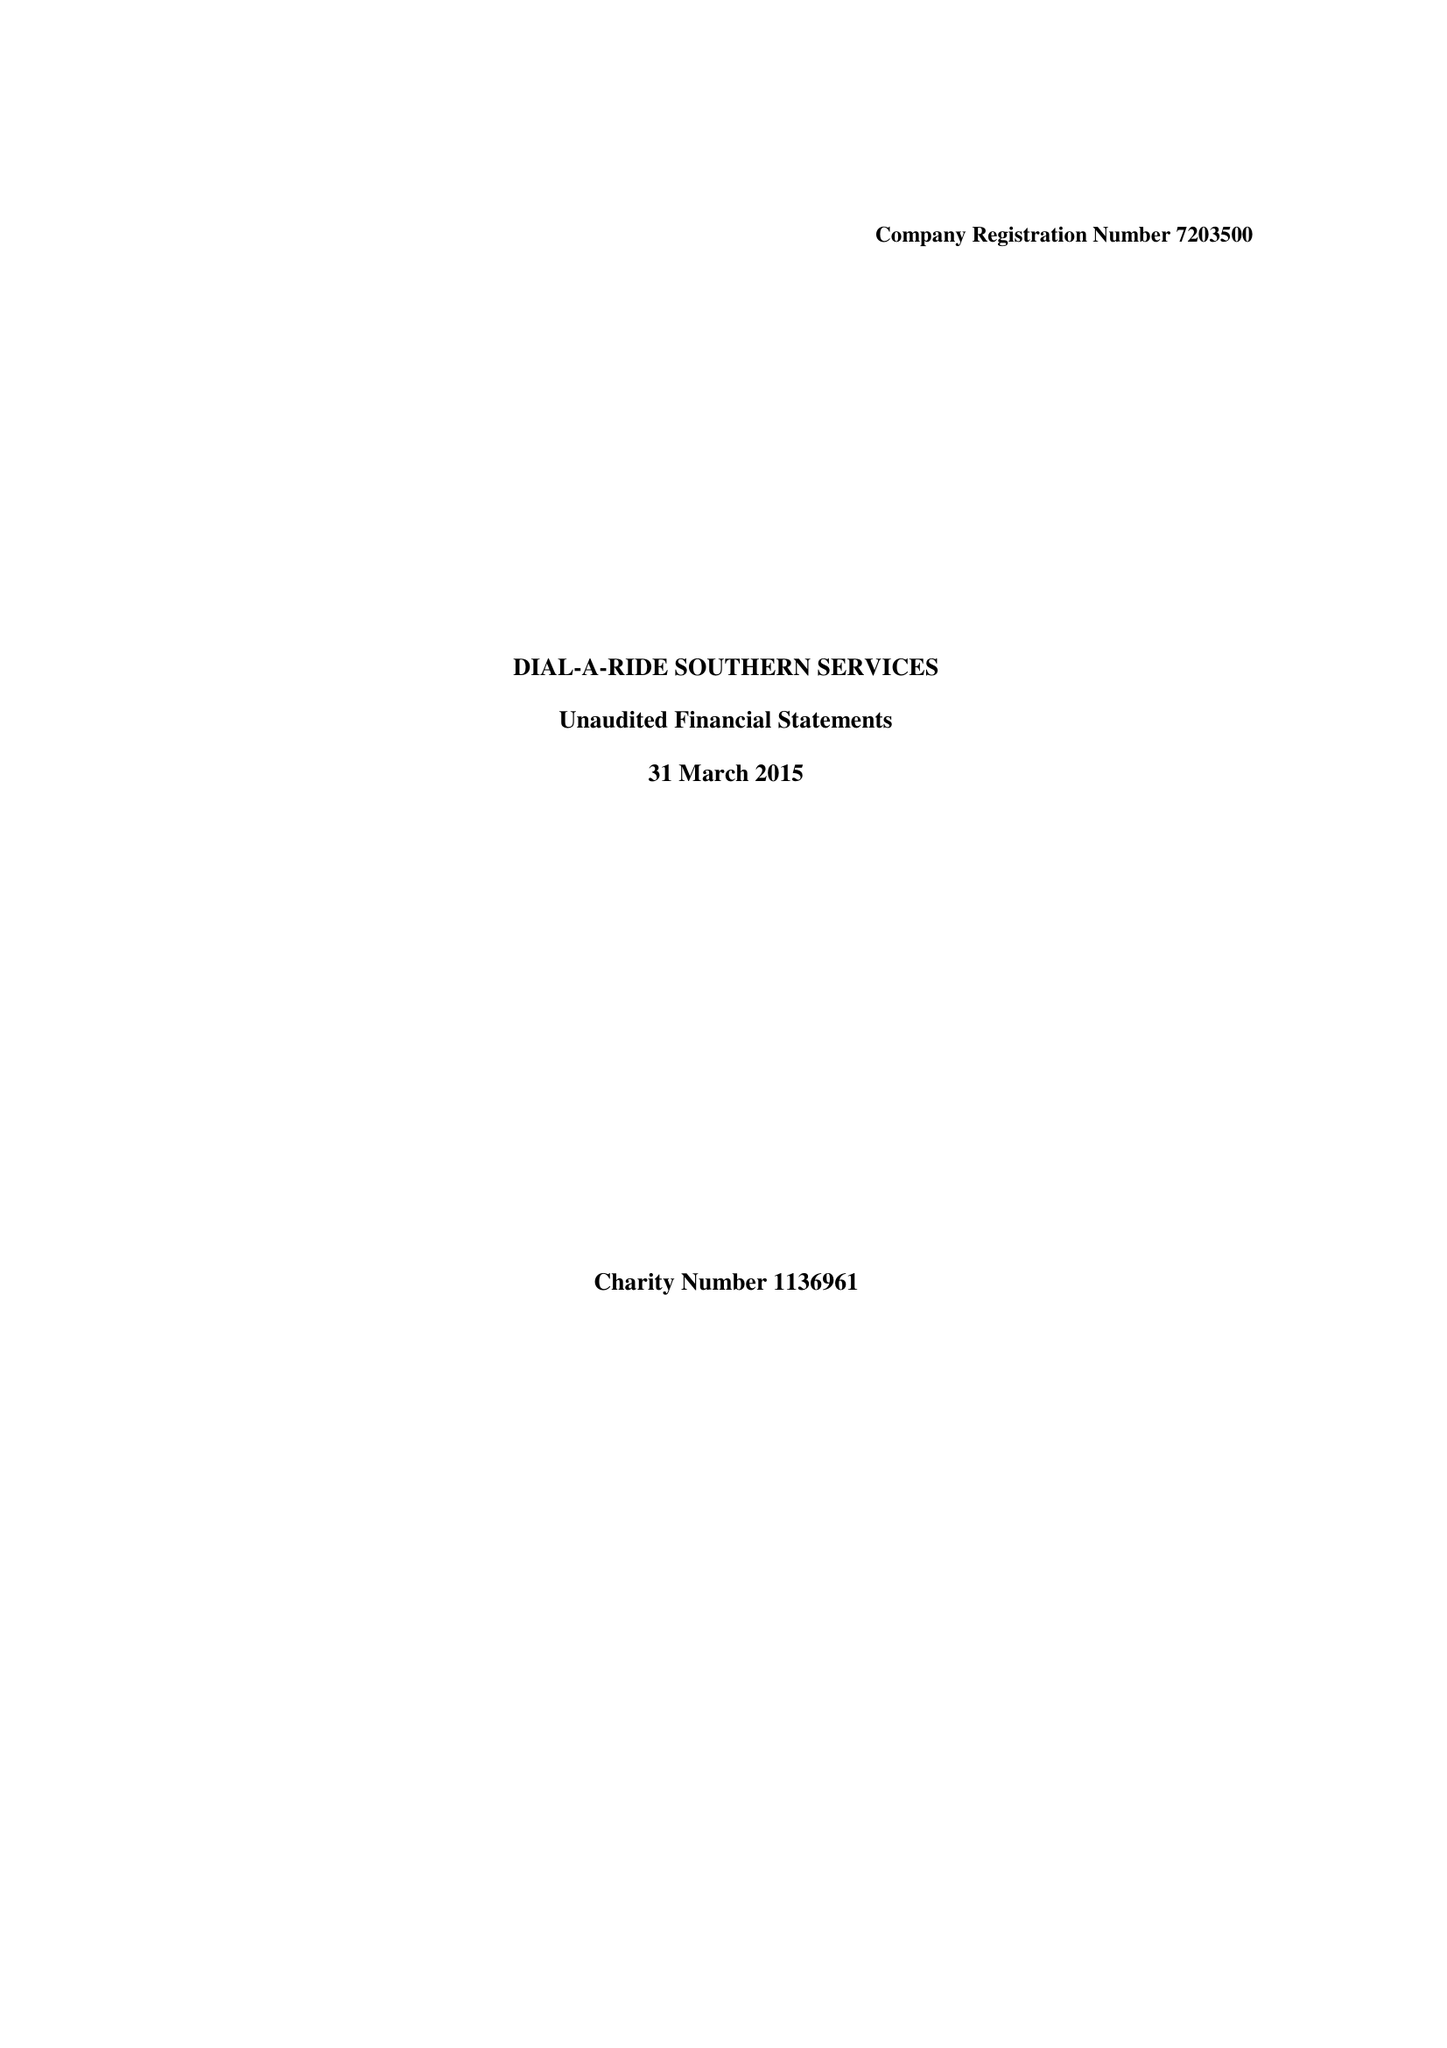What is the value for the address__postcode?
Answer the question using a single word or phrase. BN12 6JD 